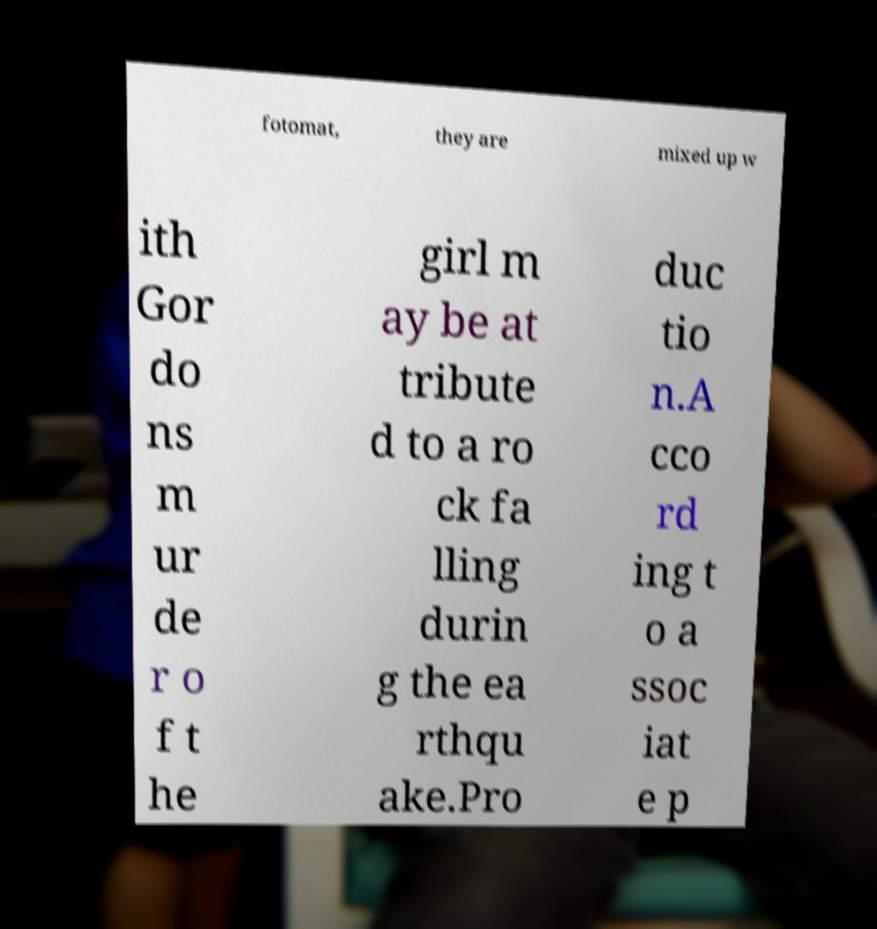What messages or text are displayed in this image? I need them in a readable, typed format. fotomat, they are mixed up w ith Gor do ns m ur de r o f t he girl m ay be at tribute d to a ro ck fa lling durin g the ea rthqu ake.Pro duc tio n.A cco rd ing t o a ssoc iat e p 